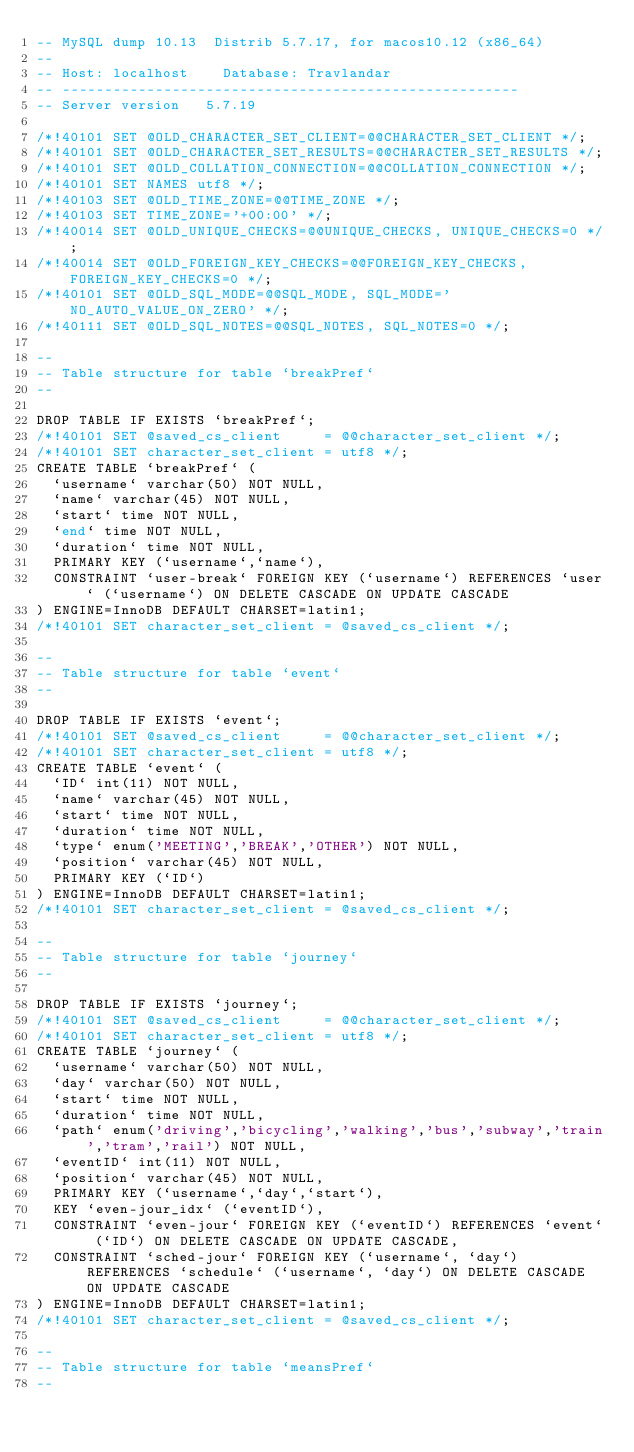Convert code to text. <code><loc_0><loc_0><loc_500><loc_500><_SQL_>-- MySQL dump 10.13  Distrib 5.7.17, for macos10.12 (x86_64)
--
-- Host: localhost    Database: Travlandar
-- ------------------------------------------------------
-- Server version	5.7.19

/*!40101 SET @OLD_CHARACTER_SET_CLIENT=@@CHARACTER_SET_CLIENT */;
/*!40101 SET @OLD_CHARACTER_SET_RESULTS=@@CHARACTER_SET_RESULTS */;
/*!40101 SET @OLD_COLLATION_CONNECTION=@@COLLATION_CONNECTION */;
/*!40101 SET NAMES utf8 */;
/*!40103 SET @OLD_TIME_ZONE=@@TIME_ZONE */;
/*!40103 SET TIME_ZONE='+00:00' */;
/*!40014 SET @OLD_UNIQUE_CHECKS=@@UNIQUE_CHECKS, UNIQUE_CHECKS=0 */;
/*!40014 SET @OLD_FOREIGN_KEY_CHECKS=@@FOREIGN_KEY_CHECKS, FOREIGN_KEY_CHECKS=0 */;
/*!40101 SET @OLD_SQL_MODE=@@SQL_MODE, SQL_MODE='NO_AUTO_VALUE_ON_ZERO' */;
/*!40111 SET @OLD_SQL_NOTES=@@SQL_NOTES, SQL_NOTES=0 */;

--
-- Table structure for table `breakPref`
--

DROP TABLE IF EXISTS `breakPref`;
/*!40101 SET @saved_cs_client     = @@character_set_client */;
/*!40101 SET character_set_client = utf8 */;
CREATE TABLE `breakPref` (
  `username` varchar(50) NOT NULL,
  `name` varchar(45) NOT NULL,
  `start` time NOT NULL,
  `end` time NOT NULL,
  `duration` time NOT NULL,
  PRIMARY KEY (`username`,`name`),
  CONSTRAINT `user-break` FOREIGN KEY (`username`) REFERENCES `user` (`username`) ON DELETE CASCADE ON UPDATE CASCADE
) ENGINE=InnoDB DEFAULT CHARSET=latin1;
/*!40101 SET character_set_client = @saved_cs_client */;

--
-- Table structure for table `event`
--

DROP TABLE IF EXISTS `event`;
/*!40101 SET @saved_cs_client     = @@character_set_client */;
/*!40101 SET character_set_client = utf8 */;
CREATE TABLE `event` (
  `ID` int(11) NOT NULL,
  `name` varchar(45) NOT NULL,
  `start` time NOT NULL,
  `duration` time NOT NULL,
  `type` enum('MEETING','BREAK','OTHER') NOT NULL,
  `position` varchar(45) NOT NULL,
  PRIMARY KEY (`ID`)
) ENGINE=InnoDB DEFAULT CHARSET=latin1;
/*!40101 SET character_set_client = @saved_cs_client */;

--
-- Table structure for table `journey`
--

DROP TABLE IF EXISTS `journey`;
/*!40101 SET @saved_cs_client     = @@character_set_client */;
/*!40101 SET character_set_client = utf8 */;
CREATE TABLE `journey` (
  `username` varchar(50) NOT NULL,
  `day` varchar(50) NOT NULL,
  `start` time NOT NULL,
  `duration` time NOT NULL,
  `path` enum('driving','bicycling','walking','bus','subway','train','tram','rail') NOT NULL,
  `eventID` int(11) NOT NULL,
  `position` varchar(45) NOT NULL,
  PRIMARY KEY (`username`,`day`,`start`),
  KEY `even-jour_idx` (`eventID`),
  CONSTRAINT `even-jour` FOREIGN KEY (`eventID`) REFERENCES `event` (`ID`) ON DELETE CASCADE ON UPDATE CASCADE,
  CONSTRAINT `sched-jour` FOREIGN KEY (`username`, `day`) REFERENCES `schedule` (`username`, `day`) ON DELETE CASCADE ON UPDATE CASCADE
) ENGINE=InnoDB DEFAULT CHARSET=latin1;
/*!40101 SET character_set_client = @saved_cs_client */;

--
-- Table structure for table `meansPref`
--
</code> 